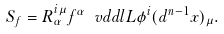Convert formula to latex. <formula><loc_0><loc_0><loc_500><loc_500>S _ { f } = R ^ { i \mu } _ { \alpha } f ^ { \alpha } \ v d d l { L } { \phi ^ { i } } ( d ^ { n - 1 } x ) _ { \mu } .</formula> 